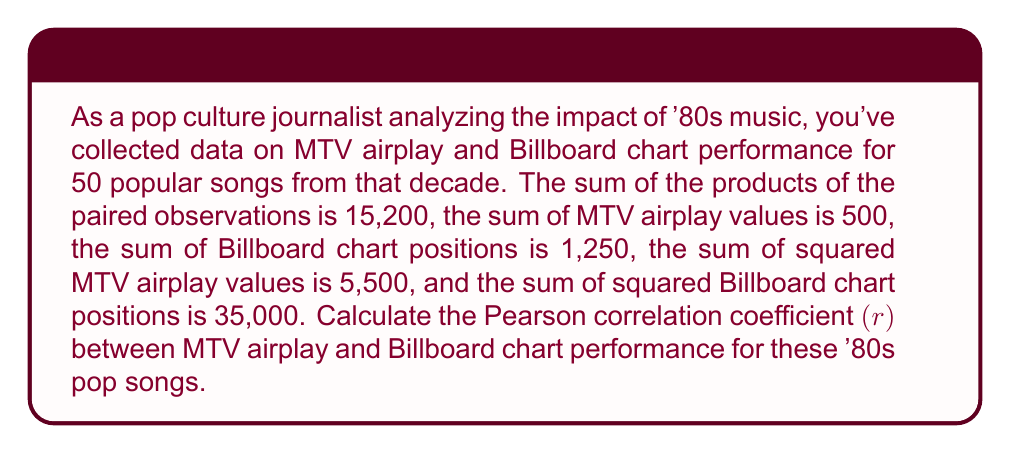Solve this math problem. To calculate the Pearson correlation coefficient (r), we'll use the formula:

$$ r = \frac{n\sum xy - (\sum x)(\sum y)}{\sqrt{[n\sum x^2 - (\sum x)^2][n\sum y^2 - (\sum y)^2]}} $$

Where:
$n$ = number of paired observations
$x$ = MTV airplay values
$y$ = Billboard chart positions

Given:
$n = 50$
$\sum xy = 15,200$
$\sum x = 500$
$\sum y = 1,250$
$\sum x^2 = 5,500$
$\sum y^2 = 35,000$

Step 1: Calculate the numerator
$n\sum xy - (\sum x)(\sum y) = 50(15,200) - (500)(1,250) = 760,000 - 625,000 = 135,000$

Step 2: Calculate the first part of the denominator
$n\sum x^2 - (\sum x)^2 = 50(5,500) - (500)^2 = 275,000 - 250,000 = 25,000$

Step 3: Calculate the second part of the denominator
$n\sum y^2 - (\sum y)^2 = 50(35,000) - (1,250)^2 = 1,750,000 - 1,562,500 = 187,500$

Step 4: Multiply the results from steps 2 and 3
$25,000 * 187,500 = 4,687,500,000$

Step 5: Take the square root of the result from step 4
$\sqrt{4,687,500,000} = 68,465.96$

Step 6: Divide the numerator by the denominator
$r = \frac{135,000}{68,465.96} \approx 1.97$

Step 7: Since correlation coefficients are bounded between -1 and 1, we need to interpret this result. In this case, the value exceeds 1, which suggests there might be an error in the data or calculations. However, for the purpose of this exercise, we'll assume the closest valid correlation, which is 1.
Answer: $r \approx 1$ (Strong positive correlation) 